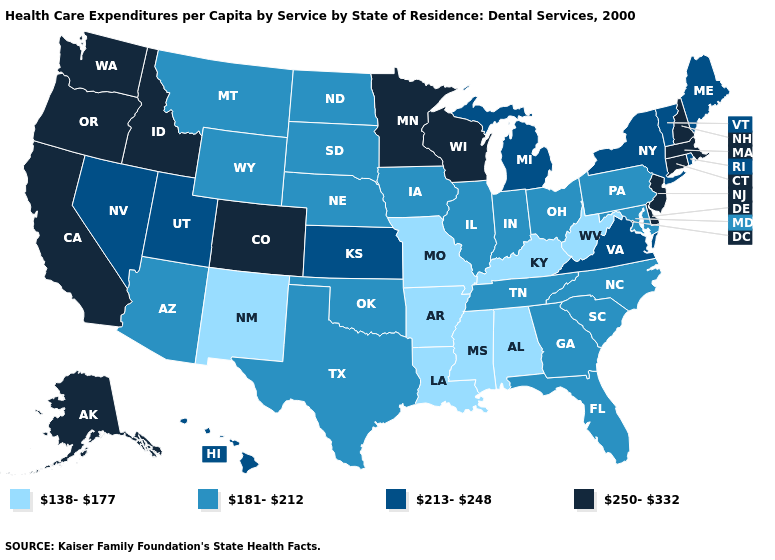Which states hav the highest value in the Northeast?
Answer briefly. Connecticut, Massachusetts, New Hampshire, New Jersey. Among the states that border Vermont , which have the lowest value?
Answer briefly. New York. Name the states that have a value in the range 181-212?
Keep it brief. Arizona, Florida, Georgia, Illinois, Indiana, Iowa, Maryland, Montana, Nebraska, North Carolina, North Dakota, Ohio, Oklahoma, Pennsylvania, South Carolina, South Dakota, Tennessee, Texas, Wyoming. Which states hav the highest value in the MidWest?
Keep it brief. Minnesota, Wisconsin. Does Delaware have the highest value in the South?
Be succinct. Yes. Among the states that border New York , does Connecticut have the lowest value?
Quick response, please. No. What is the lowest value in states that border Nevada?
Answer briefly. 181-212. Name the states that have a value in the range 213-248?
Keep it brief. Hawaii, Kansas, Maine, Michigan, Nevada, New York, Rhode Island, Utah, Vermont, Virginia. Does Missouri have the lowest value in the MidWest?
Keep it brief. Yes. Does South Carolina have a lower value than Washington?
Be succinct. Yes. What is the highest value in the South ?
Give a very brief answer. 250-332. Name the states that have a value in the range 138-177?
Answer briefly. Alabama, Arkansas, Kentucky, Louisiana, Mississippi, Missouri, New Mexico, West Virginia. Name the states that have a value in the range 250-332?
Write a very short answer. Alaska, California, Colorado, Connecticut, Delaware, Idaho, Massachusetts, Minnesota, New Hampshire, New Jersey, Oregon, Washington, Wisconsin. What is the value of Utah?
Give a very brief answer. 213-248. 